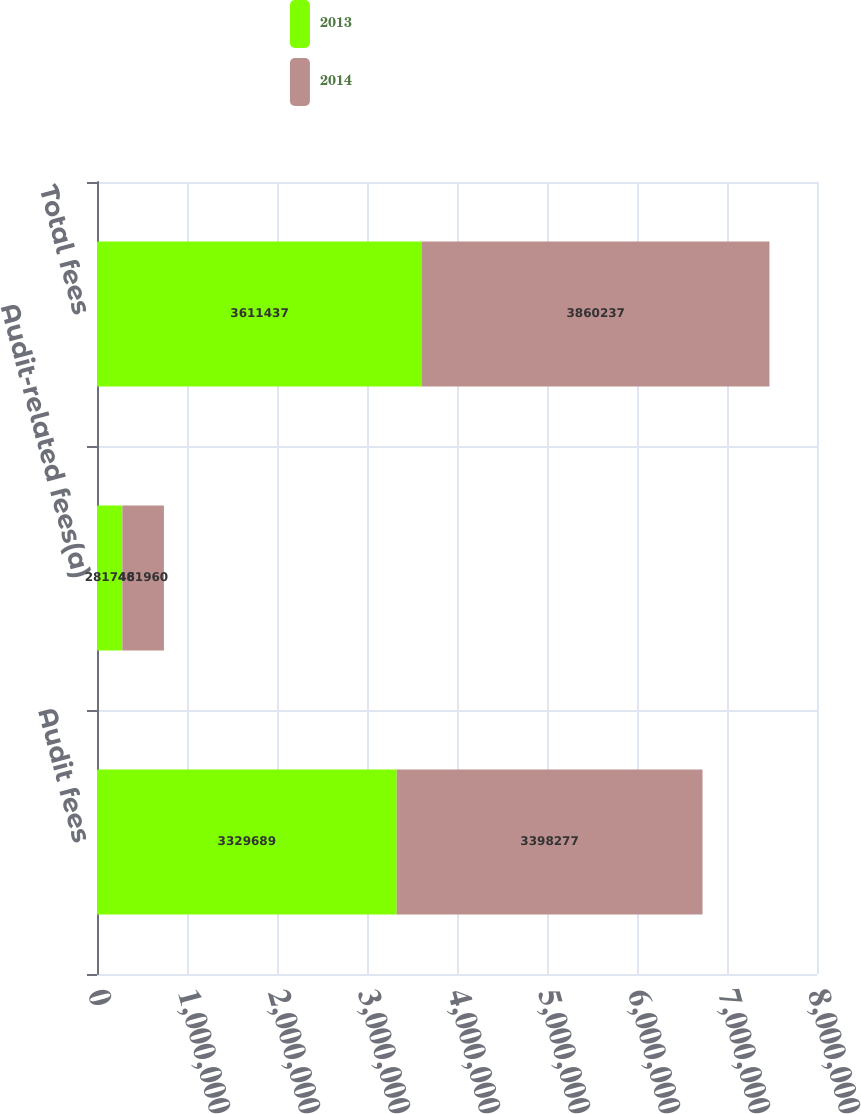Convert chart. <chart><loc_0><loc_0><loc_500><loc_500><stacked_bar_chart><ecel><fcel>Audit fees<fcel>Audit-related fees(a)<fcel>Total fees<nl><fcel>2013<fcel>3.32969e+06<fcel>281748<fcel>3.61144e+06<nl><fcel>2014<fcel>3.39828e+06<fcel>461960<fcel>3.86024e+06<nl></chart> 